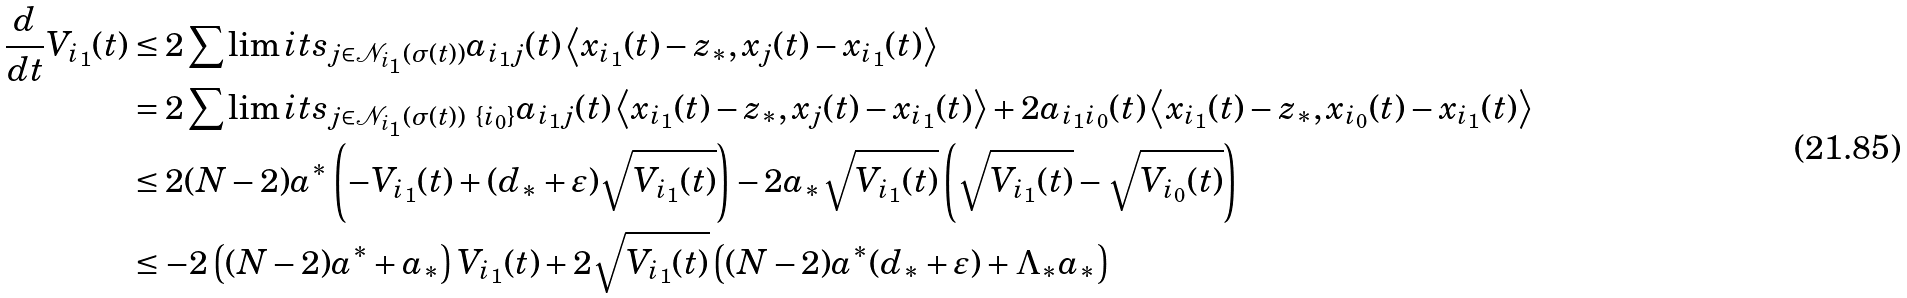Convert formula to latex. <formula><loc_0><loc_0><loc_500><loc_500>\frac { d } { d t } V _ { i _ { 1 } } ( t ) & \leq 2 \sum \lim i t s _ { j \in \mathcal { N } _ { i _ { 1 } } ( \sigma ( t ) ) } a _ { i _ { 1 } j } ( t ) \left \langle x _ { i _ { 1 } } ( t ) - z _ { \ast } , x _ { j } ( t ) - x _ { i _ { 1 } } ( t ) \right \rangle \\ & = 2 \sum \lim i t s _ { j \in \mathcal { N } _ { i _ { 1 } } ( \sigma ( t ) ) \ \{ i _ { 0 } \} } a _ { i _ { 1 } j } ( t ) \left \langle x _ { i _ { 1 } } ( t ) - z _ { \ast } , x _ { j } ( t ) - x _ { i _ { 1 } } ( t ) \right \rangle + 2 a _ { i _ { 1 } i _ { 0 } } ( t ) \left \langle x _ { i _ { 1 } } ( t ) - z _ { \ast } , x _ { i _ { 0 } } ( t ) - x _ { i _ { 1 } } ( t ) \right \rangle \\ & \leq 2 ( N - 2 ) a ^ { \ast } \left ( - V _ { i _ { 1 } } ( t ) + ( d _ { \ast } + \varepsilon ) \sqrt { V _ { i _ { 1 } } ( t ) } \right ) - 2 a _ { \ast } \sqrt { V _ { i _ { 1 } } ( t ) } \left ( \sqrt { V _ { i _ { 1 } } ( t ) } - \sqrt { V _ { i _ { 0 } } ( t ) } \right ) \\ & \leq - 2 \left ( ( N - 2 ) a ^ { \ast } + a _ { \ast } \right ) V _ { i _ { 1 } } ( t ) + 2 \sqrt { V _ { i _ { 1 } } ( t ) } \left ( ( N - 2 ) a ^ { \ast } ( d _ { \ast } + \varepsilon ) + \Lambda _ { \ast } a _ { \ast } \right )</formula> 